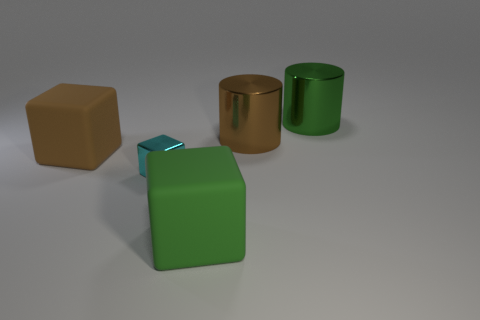How big is the green thing behind the large green rubber thing? The green item behind the larger green object appears to be smaller in size. It's difficult to provide precise dimensions without context, but it seems to be a medium-sized object relative to the larger green one in front. 